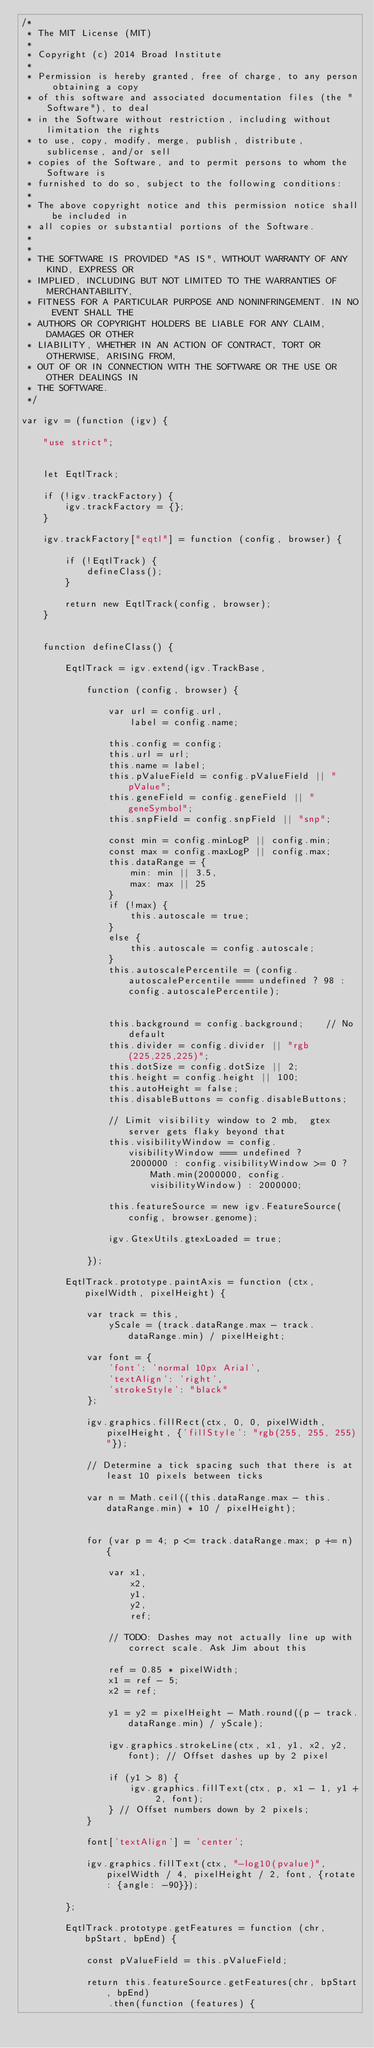Convert code to text. <code><loc_0><loc_0><loc_500><loc_500><_JavaScript_>/*
 * The MIT License (MIT)
 *
 * Copyright (c) 2014 Broad Institute
 *
 * Permission is hereby granted, free of charge, to any person obtaining a copy
 * of this software and associated documentation files (the "Software"), to deal
 * in the Software without restriction, including without limitation the rights
 * to use, copy, modify, merge, publish, distribute, sublicense, and/or sell
 * copies of the Software, and to permit persons to whom the Software is
 * furnished to do so, subject to the following conditions:
 *
 * The above copyright notice and this permission notice shall be included in
 * all copies or substantial portions of the Software.
 *
 *
 * THE SOFTWARE IS PROVIDED "AS IS", WITHOUT WARRANTY OF ANY KIND, EXPRESS OR
 * IMPLIED, INCLUDING BUT NOT LIMITED TO THE WARRANTIES OF MERCHANTABILITY,
 * FITNESS FOR A PARTICULAR PURPOSE AND NONINFRINGEMENT. IN NO EVENT SHALL THE
 * AUTHORS OR COPYRIGHT HOLDERS BE LIABLE FOR ANY CLAIM, DAMAGES OR OTHER
 * LIABILITY, WHETHER IN AN ACTION OF CONTRACT, TORT OR OTHERWISE, ARISING FROM,
 * OUT OF OR IN CONNECTION WITH THE SOFTWARE OR THE USE OR OTHER DEALINGS IN
 * THE SOFTWARE.
 */

var igv = (function (igv) {

    "use strict";


    let EqtlTrack;

    if (!igv.trackFactory) {
        igv.trackFactory = {};
    }

    igv.trackFactory["eqtl"] = function (config, browser) {

        if (!EqtlTrack) {
            defineClass();
        }

        return new EqtlTrack(config, browser);
    }


    function defineClass() {

        EqtlTrack = igv.extend(igv.TrackBase,

            function (config, browser) {

                var url = config.url,
                    label = config.name;

                this.config = config;
                this.url = url;
                this.name = label;
                this.pValueField = config.pValueField || "pValue";
                this.geneField = config.geneField || "geneSymbol";
                this.snpField = config.snpField || "snp";

                const min = config.minLogP || config.min;
                const max = config.maxLogP || config.max;
                this.dataRange = {
                    min: min || 3.5,
                    max: max || 25
                }
                if (!max) {
                    this.autoscale = true;
                }
                else {
                    this.autoscale = config.autoscale;
                }
                this.autoscalePercentile = (config.autoscalePercentile === undefined ? 98 : config.autoscalePercentile);


                this.background = config.background;    // No default
                this.divider = config.divider || "rgb(225,225,225)";
                this.dotSize = config.dotSize || 2;
                this.height = config.height || 100;
                this.autoHeight = false;
                this.disableButtons = config.disableButtons;

                // Limit visibility window to 2 mb,  gtex server gets flaky beyond that
                this.visibilityWindow = config.visibilityWindow === undefined ?
                    2000000 : config.visibilityWindow >= 0 ? Math.min(2000000, config.visibilityWindow) : 2000000;

                this.featureSource = new igv.FeatureSource(config, browser.genome);

                igv.GtexUtils.gtexLoaded = true;

            });

        EqtlTrack.prototype.paintAxis = function (ctx, pixelWidth, pixelHeight) {

            var track = this,
                yScale = (track.dataRange.max - track.dataRange.min) / pixelHeight;

            var font = {
                'font': 'normal 10px Arial',
                'textAlign': 'right',
                'strokeStyle': "black"
            };

            igv.graphics.fillRect(ctx, 0, 0, pixelWidth, pixelHeight, {'fillStyle': "rgb(255, 255, 255)"});

            // Determine a tick spacing such that there is at least 10 pixels between ticks

            var n = Math.ceil((this.dataRange.max - this.dataRange.min) * 10 / pixelHeight);


            for (var p = 4; p <= track.dataRange.max; p += n) {

                var x1,
                    x2,
                    y1,
                    y2,
                    ref;

                // TODO: Dashes may not actually line up with correct scale. Ask Jim about this

                ref = 0.85 * pixelWidth;
                x1 = ref - 5;
                x2 = ref;

                y1 = y2 = pixelHeight - Math.round((p - track.dataRange.min) / yScale);

                igv.graphics.strokeLine(ctx, x1, y1, x2, y2, font); // Offset dashes up by 2 pixel

                if (y1 > 8) {
                    igv.graphics.fillText(ctx, p, x1 - 1, y1 + 2, font);
                } // Offset numbers down by 2 pixels;
            }

            font['textAlign'] = 'center';

            igv.graphics.fillText(ctx, "-log10(pvalue)", pixelWidth / 4, pixelHeight / 2, font, {rotate: {angle: -90}});

        };

        EqtlTrack.prototype.getFeatures = function (chr, bpStart, bpEnd) {

            const pValueField = this.pValueField;

            return this.featureSource.getFeatures(chr, bpStart, bpEnd)
                .then(function (features) {</code> 